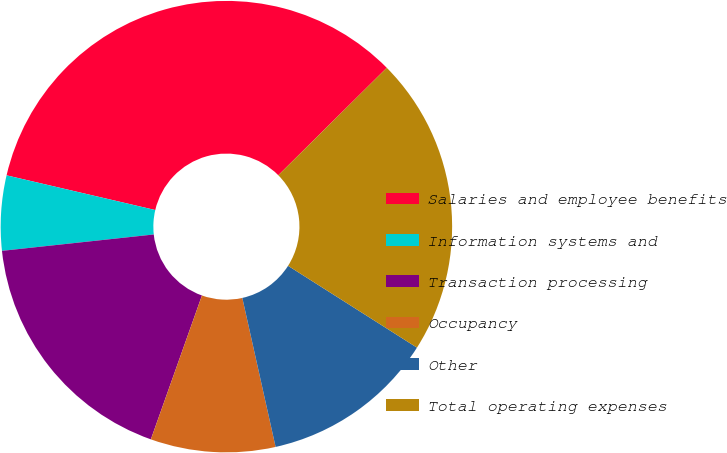Convert chart to OTSL. <chart><loc_0><loc_0><loc_500><loc_500><pie_chart><fcel>Salaries and employee benefits<fcel>Information systems and<fcel>Transaction processing<fcel>Occupancy<fcel>Other<fcel>Total operating expenses<nl><fcel>33.93%<fcel>5.36%<fcel>17.86%<fcel>8.93%<fcel>12.5%<fcel>21.43%<nl></chart> 